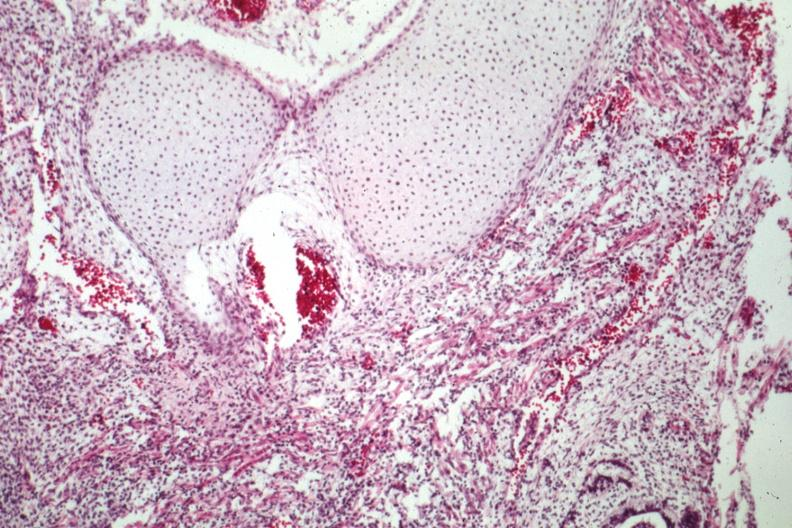what does this image show?
Answer the question using a single word or phrase. Lung tissue and cartilage 